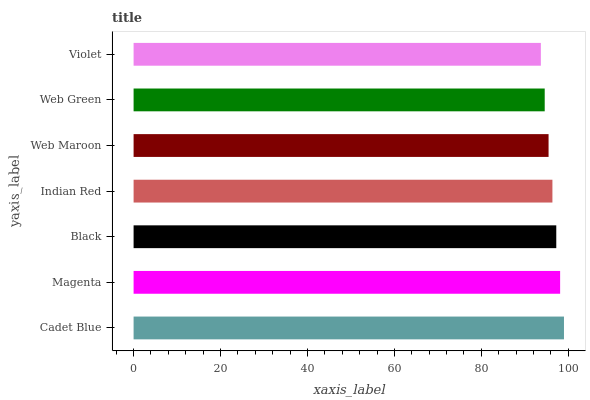Is Violet the minimum?
Answer yes or no. Yes. Is Cadet Blue the maximum?
Answer yes or no. Yes. Is Magenta the minimum?
Answer yes or no. No. Is Magenta the maximum?
Answer yes or no. No. Is Cadet Blue greater than Magenta?
Answer yes or no. Yes. Is Magenta less than Cadet Blue?
Answer yes or no. Yes. Is Magenta greater than Cadet Blue?
Answer yes or no. No. Is Cadet Blue less than Magenta?
Answer yes or no. No. Is Indian Red the high median?
Answer yes or no. Yes. Is Indian Red the low median?
Answer yes or no. Yes. Is Web Maroon the high median?
Answer yes or no. No. Is Web Maroon the low median?
Answer yes or no. No. 